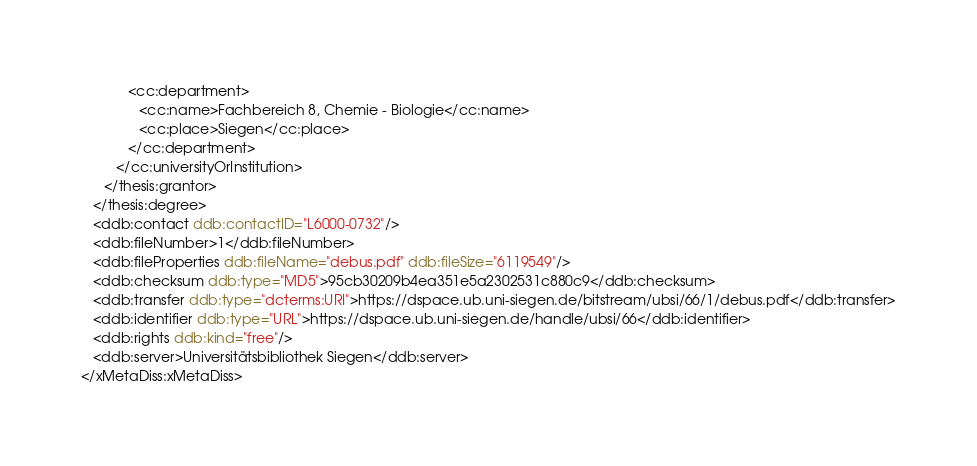<code> <loc_0><loc_0><loc_500><loc_500><_XML_>            <cc:department>
               <cc:name>Fachbereich 8, Chemie - Biologie</cc:name>
               <cc:place>Siegen</cc:place>
            </cc:department>
         </cc:universityOrInstitution>
      </thesis:grantor>
   </thesis:degree>
   <ddb:contact ddb:contactID="L6000-0732"/>
   <ddb:fileNumber>1</ddb:fileNumber>
   <ddb:fileProperties ddb:fileName="debus.pdf" ddb:fileSize="6119549"/>
   <ddb:checksum ddb:type="MD5">95cb30209b4ea351e5a2302531c880c9</ddb:checksum>
   <ddb:transfer ddb:type="dcterms:URI">https://dspace.ub.uni-siegen.de/bitstream/ubsi/66/1/debus.pdf</ddb:transfer>
   <ddb:identifier ddb:type="URL">https://dspace.ub.uni-siegen.de/handle/ubsi/66</ddb:identifier>
   <ddb:rights ddb:kind="free"/>
   <ddb:server>Universitätsbibliothek Siegen</ddb:server>
</xMetaDiss:xMetaDiss></code> 